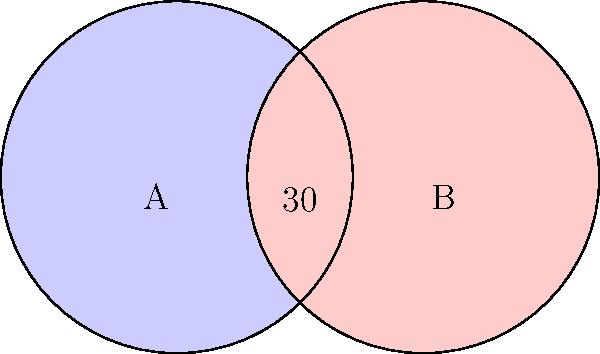Bernice is creating a Venn diagram artwork featuring two overlapping circles, each with a radius of 50 units. The centers of the circles are 70 units apart. What is the area of the overlapping region (intersection) of the two circles? Round your answer to the nearest square unit. Let's approach this step-by-step:

1) First, we need to find the angle $\theta$ at the center of each circle that corresponds to the overlapping region.

2) We can do this using the cosine formula:
   $$\cos(\theta/2) = \frac{70/2}{50} = 0.7$$

3) Therefore, $\theta/2 = \arccos(0.7)$, and $\theta = 2\arccos(0.7)$

4) The area of a sector of a circle is given by $\frac{\theta}{2\pi} \pi r^2 = \frac{\theta r^2}{2}$

5) The area of the triangle formed by the two radii and the line connecting the centers is $\frac{1}{2} \cdot 50 \cdot 50 \cdot \sin(\theta)$

6) The area of the overlapping region is twice the difference between the sector and the triangle:

   $$A = 2(\frac{\theta r^2}{2} - \frac{1}{2} \cdot 50 \cdot 50 \cdot \sin(\theta))$$
   $$A = 50^2(\theta - \sin(\theta))$$
   $$A = 2500(2\arccos(0.7) - \sin(2\arccos(0.7)))$$

7) Calculating this and rounding to the nearest square unit:
   $$A \approx 1376$$ square units
Answer: 1376 square units 